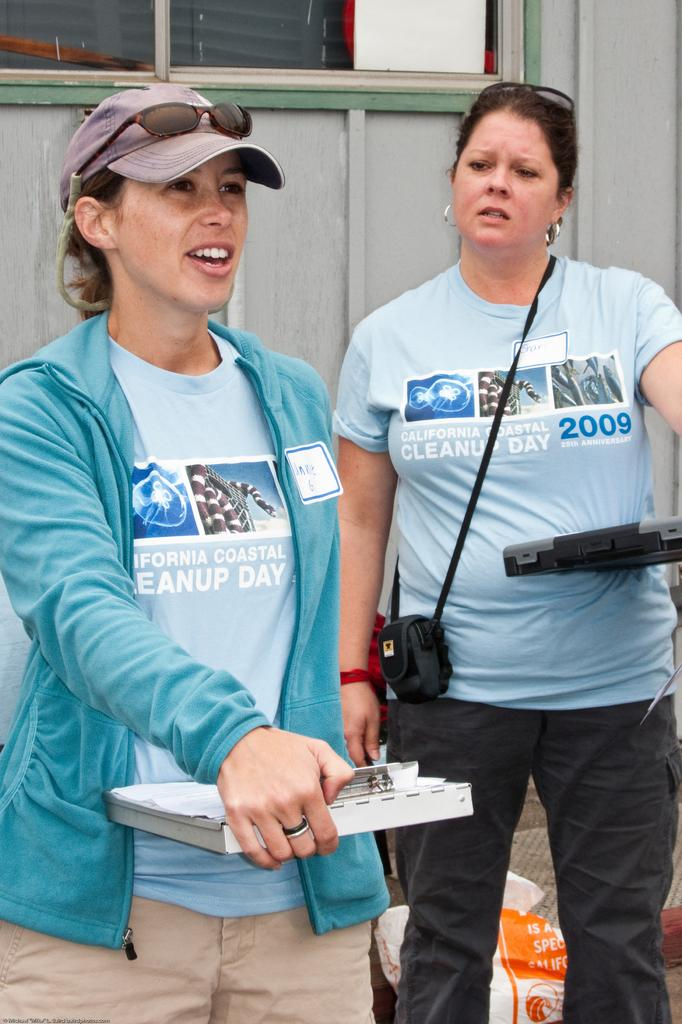<image>
Present a compact description of the photo's key features. Two women wearing California Coastal Cleanup Day shirts prepare to work. 